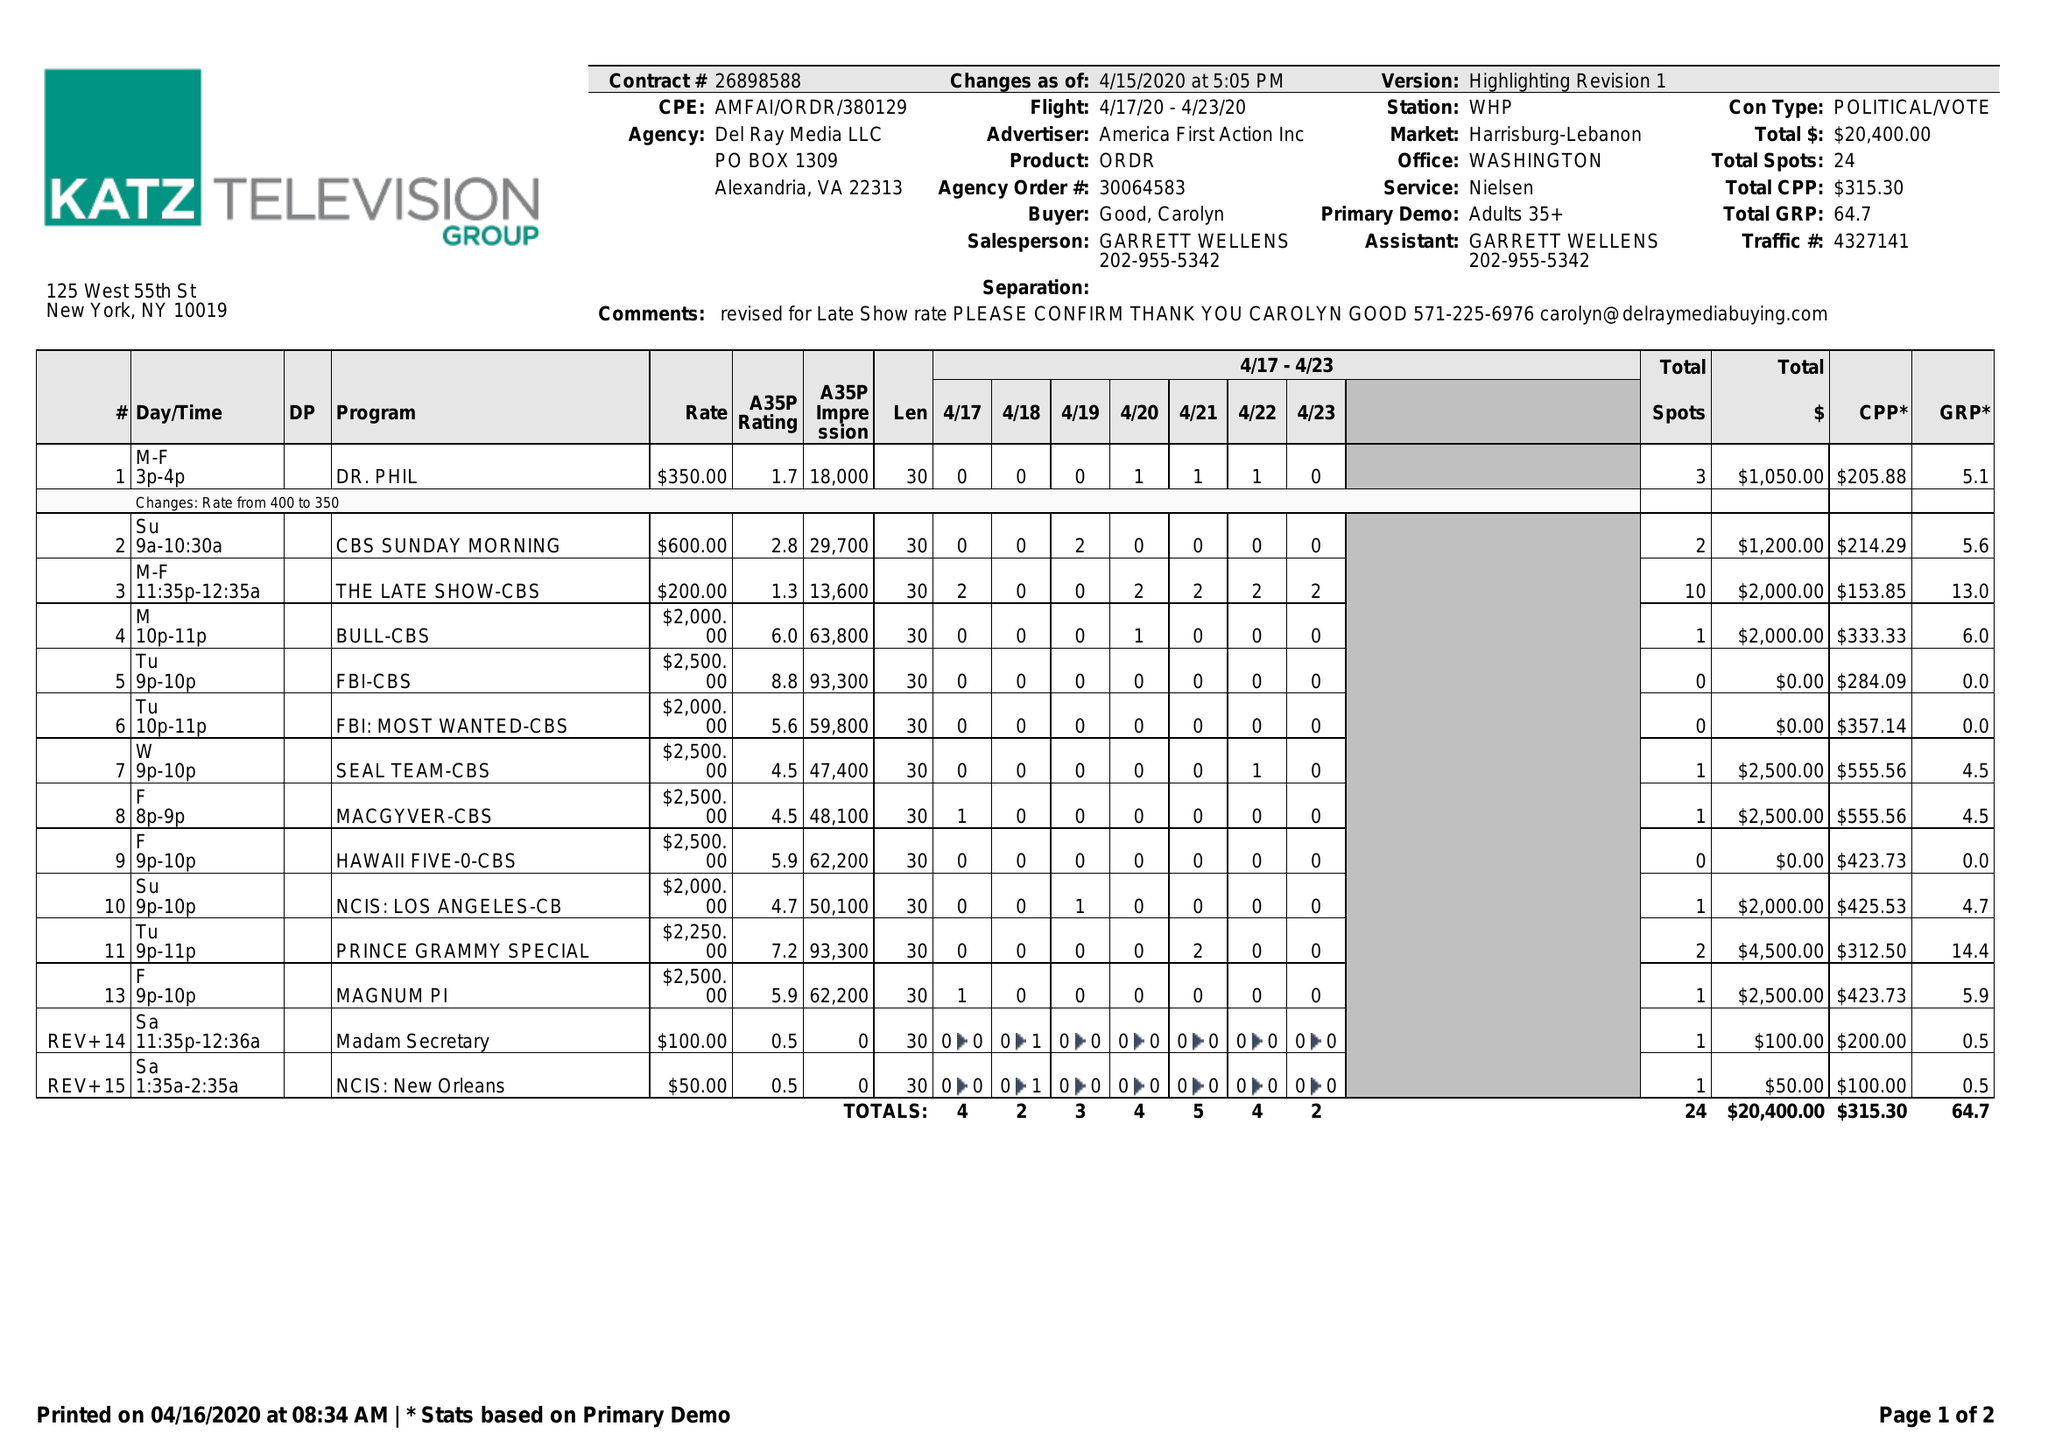What is the value for the contract_num?
Answer the question using a single word or phrase. 26898588 